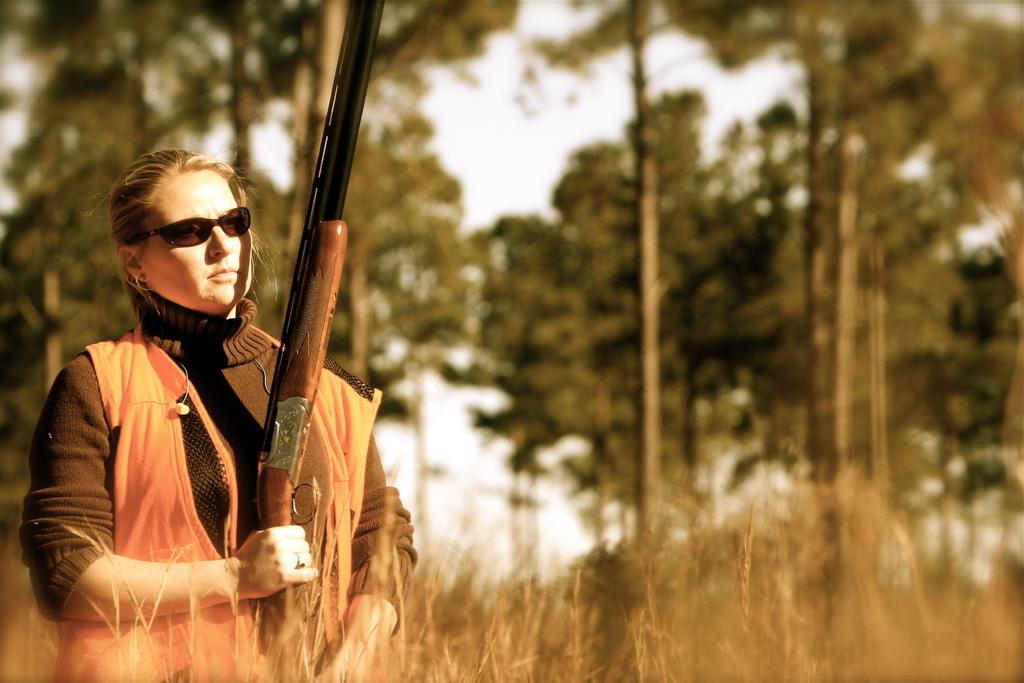Who is present in the image? There is a woman in the image. What is the woman holding in the image? The woman is holding a gun. What can be seen in the background of the image? There are trees and the sky visible in the background of the image. What grade does the woman receive for her performance in the image? There is no indication of a performance or grading system in the image, so it cannot be determined. 